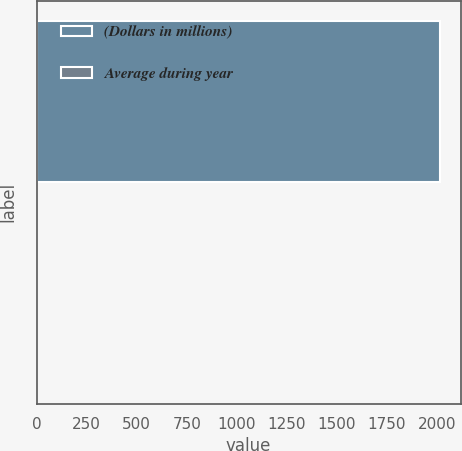Convert chart. <chart><loc_0><loc_0><loc_500><loc_500><bar_chart><fcel>(Dollars in millions)<fcel>Average during year<nl><fcel>2018<fcel>1.26<nl></chart> 